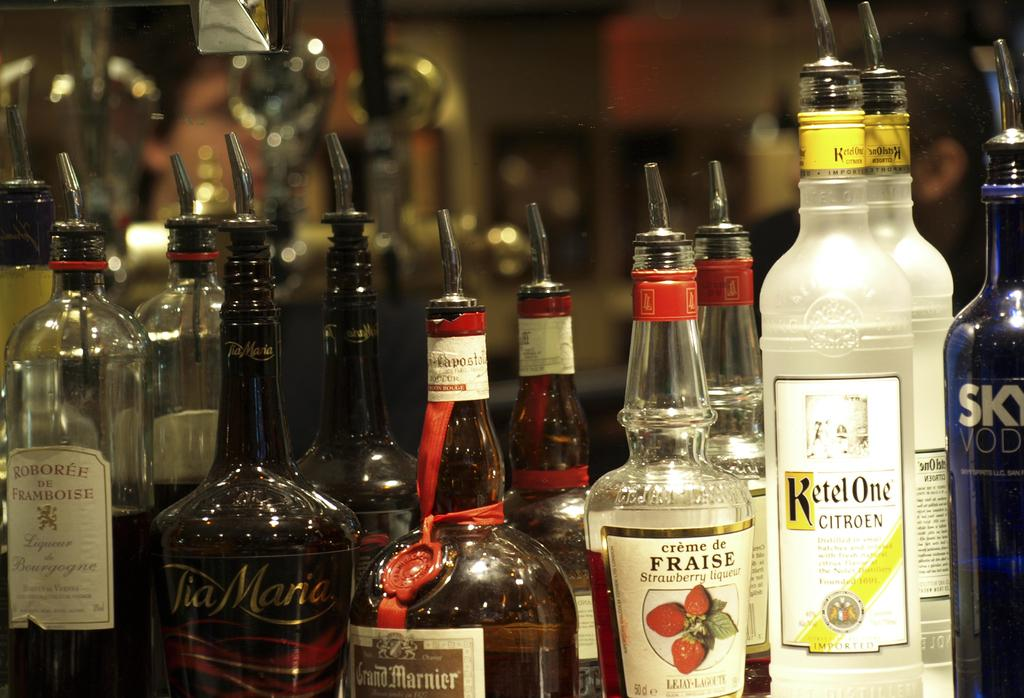<image>
Share a concise interpretation of the image provided. the words ketel one that are on a bottle 